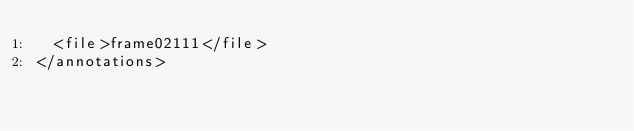Convert code to text. <code><loc_0><loc_0><loc_500><loc_500><_XML_>  <file>frame02111</file>
</annotations>
</code> 